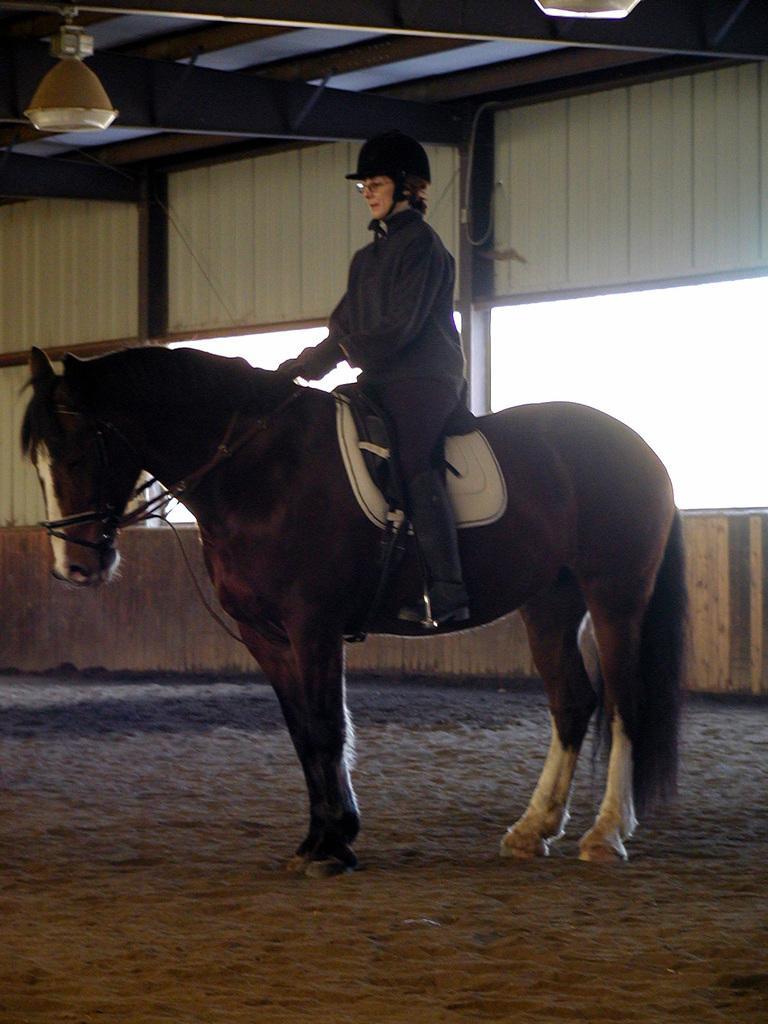In one or two sentences, can you explain what this image depicts? At the top we can see the ceiling and lights. In this picture we can see a person wearing hat, spectacles is sitting on the horse. At the bottom we can see the sand. In the background we can see the sky and the wall. 